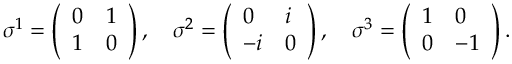Convert formula to latex. <formula><loc_0><loc_0><loc_500><loc_500>\sigma ^ { 1 } = \left ( \begin{array} { l l } { 0 } & { 1 } \\ { 1 } & { 0 } \end{array} \right ) , \quad \sigma ^ { 2 } = \left ( \begin{array} { l l } { 0 } & { i } \\ { - i } & { 0 } \end{array} \right ) , \quad \sigma ^ { 3 } = \left ( \begin{array} { l l } { 1 } & { 0 } \\ { 0 } & { - 1 } \end{array} \right ) .</formula> 